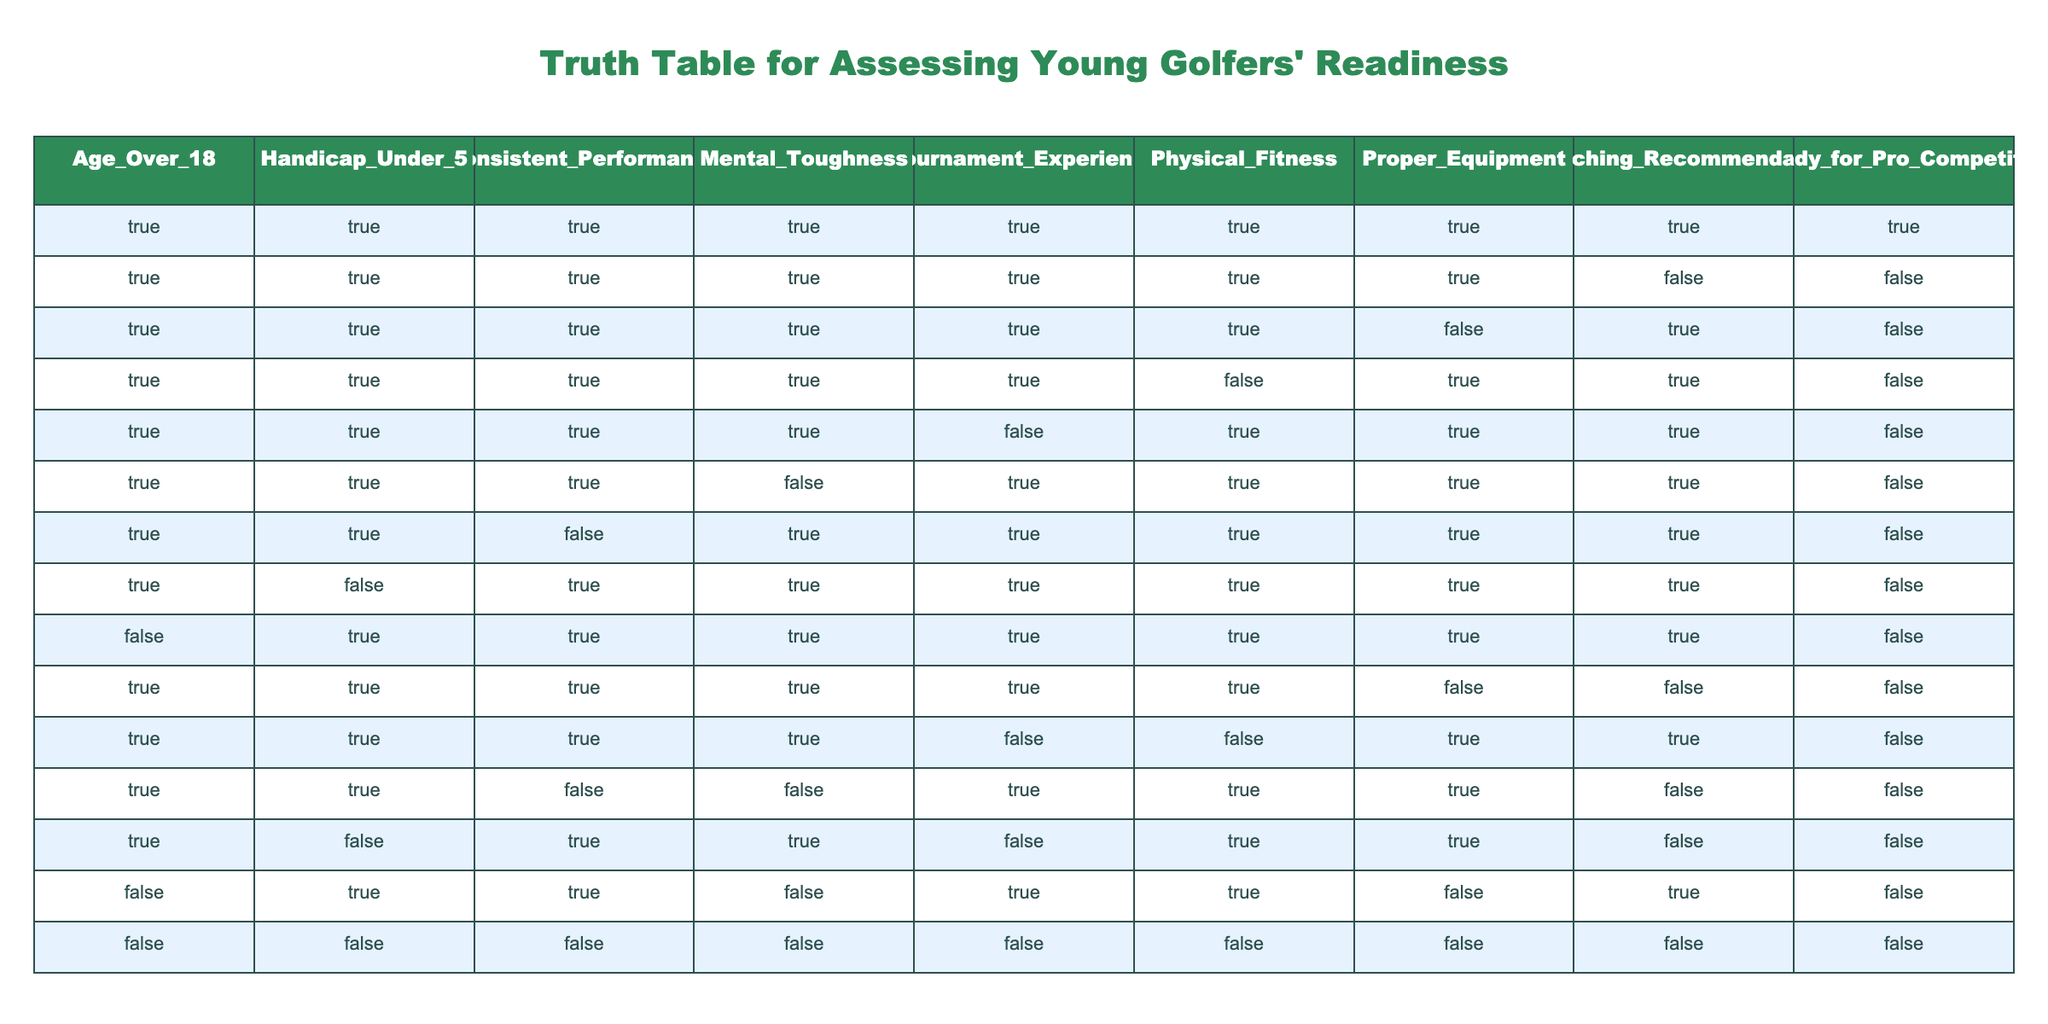What is the total number of young golfers assessed in the table? There are 15 rows in the table, each representing a young golfer's readiness assessment. Counting these reveals a total of 15 young golfers.
Answer: 15 How many young golfers are ready for professional competition? The last column indicates readiness, marked 'TRUE' for golfers ready for competition. There are 6 instances of 'TRUE' in the column indicating readiness.
Answer: 6 Is there any golfer who meets all criteria and is not ready for professional competition? Reviewing the table, there are 2 rows where all criteria are 'TRUE' but the golfer is not ready, indicated by 'FALSE' in the last column. This indicates that it is possible for golfers to meet all criteria yet not be ready.
Answer: Yes What percentage of golfers with a handicap under 5 are ready for professional competition? There are 5 golfers with 'TRUE' in the handicap column. Out of these, 3 have 'TRUE' in the readiness column. Thus, the percentage is (3/5) * 100 = 60%.
Answer: 60% How many golfers aged over 18 lack mental toughness but are still ready for professional competition? In the table, we look for rows where 'Age_Over_18' is 'TRUE', 'Mental_Toughness' is 'FALSE', and 'Ready_for_Pro_Competition' is 'TRUE'. There are 0 rows that satisfy these conditions.
Answer: 0 What criteria do young golfers fall short of most frequently among those not ready for professional competition? Analyzing the rows with 'FALSE' in the readiness column, we see that consistent performance and mental toughness are common deficiencies among those not ready. Specific counts show 5 golfers lacking consistent performance and 4 golfers lacking mental toughness.
Answer: Consistent performance In how many cases did a young golfer have proper equipment but still fell short of being ready for professional competition? By examining the table for golfers with 'TRUE' in the 'Proper_Equipment' column and 'FALSE' in the 'Ready_for_Pro_Competition' column, we find 4 such instances.
Answer: 4 What is the count of golfers with both physical fitness and coaching recommendation marked lucky who are also under the age of 18? The table shows 0 golfers with 'FALSE' in the Age_Over_18 column while also having 'TRUE' in both physical fitness and coaching recommendations, thus fulfilling the criteria.
Answer: 0 How does one golfer demonstrate physical fitness but not have a handicap under 5? The table indicates that a golfer can have 'TRUE' for physical fitness while having 'FALSE' in the handicap under 5 column, for example, the 13th row demonstrates this condition.
Answer: Yes 